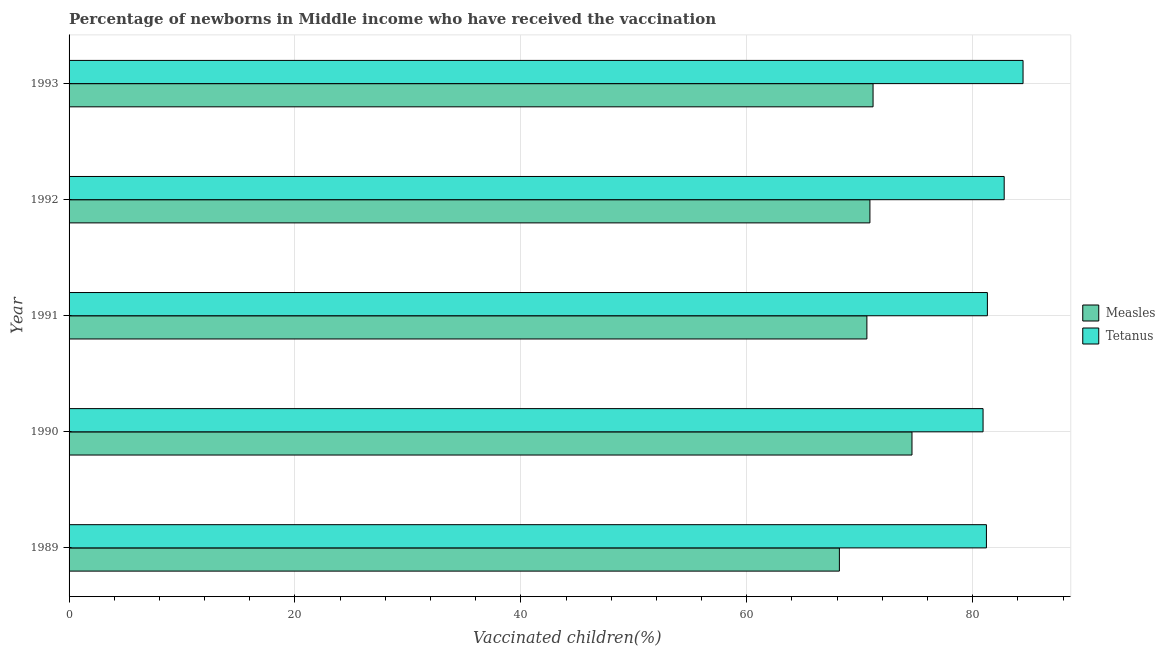Are the number of bars on each tick of the Y-axis equal?
Provide a succinct answer. Yes. In how many cases, is the number of bars for a given year not equal to the number of legend labels?
Make the answer very short. 0. What is the percentage of newborns who received vaccination for tetanus in 1989?
Give a very brief answer. 81.22. Across all years, what is the maximum percentage of newborns who received vaccination for tetanus?
Keep it short and to the point. 84.46. Across all years, what is the minimum percentage of newborns who received vaccination for measles?
Your answer should be very brief. 68.2. What is the total percentage of newborns who received vaccination for measles in the graph?
Offer a terse response. 355.55. What is the difference between the percentage of newborns who received vaccination for measles in 1989 and that in 1992?
Offer a very short reply. -2.7. What is the difference between the percentage of newborns who received vaccination for tetanus in 1992 and the percentage of newborns who received vaccination for measles in 1993?
Offer a very short reply. 11.61. What is the average percentage of newborns who received vaccination for tetanus per year?
Offer a terse response. 82.14. In the year 1993, what is the difference between the percentage of newborns who received vaccination for measles and percentage of newborns who received vaccination for tetanus?
Your answer should be compact. -13.28. What is the ratio of the percentage of newborns who received vaccination for measles in 1989 to that in 1990?
Keep it short and to the point. 0.91. Is the percentage of newborns who received vaccination for measles in 1989 less than that in 1993?
Your answer should be compact. Yes. Is the difference between the percentage of newborns who received vaccination for tetanus in 1990 and 1992 greater than the difference between the percentage of newborns who received vaccination for measles in 1990 and 1992?
Offer a terse response. No. What is the difference between the highest and the second highest percentage of newborns who received vaccination for measles?
Your answer should be compact. 3.45. What is the difference between the highest and the lowest percentage of newborns who received vaccination for measles?
Your answer should be compact. 6.43. In how many years, is the percentage of newborns who received vaccination for tetanus greater than the average percentage of newborns who received vaccination for tetanus taken over all years?
Offer a very short reply. 2. Is the sum of the percentage of newborns who received vaccination for tetanus in 1989 and 1993 greater than the maximum percentage of newborns who received vaccination for measles across all years?
Offer a terse response. Yes. What does the 1st bar from the top in 1989 represents?
Ensure brevity in your answer.  Tetanus. What does the 2nd bar from the bottom in 1991 represents?
Make the answer very short. Tetanus. Are all the bars in the graph horizontal?
Your response must be concise. Yes. What is the difference between two consecutive major ticks on the X-axis?
Your response must be concise. 20. How are the legend labels stacked?
Make the answer very short. Vertical. What is the title of the graph?
Give a very brief answer. Percentage of newborns in Middle income who have received the vaccination. Does "Overweight" appear as one of the legend labels in the graph?
Ensure brevity in your answer.  No. What is the label or title of the X-axis?
Provide a short and direct response. Vaccinated children(%)
. What is the Vaccinated children(%)
 of Measles in 1989?
Ensure brevity in your answer.  68.2. What is the Vaccinated children(%)
 in Tetanus in 1989?
Provide a short and direct response. 81.22. What is the Vaccinated children(%)
 in Measles in 1990?
Offer a terse response. 74.63. What is the Vaccinated children(%)
 of Tetanus in 1990?
Your answer should be very brief. 80.92. What is the Vaccinated children(%)
 in Measles in 1991?
Your answer should be compact. 70.64. What is the Vaccinated children(%)
 in Tetanus in 1991?
Make the answer very short. 81.3. What is the Vaccinated children(%)
 in Measles in 1992?
Keep it short and to the point. 70.9. What is the Vaccinated children(%)
 of Tetanus in 1992?
Your response must be concise. 82.79. What is the Vaccinated children(%)
 in Measles in 1993?
Your response must be concise. 71.18. What is the Vaccinated children(%)
 of Tetanus in 1993?
Your answer should be very brief. 84.46. Across all years, what is the maximum Vaccinated children(%)
 in Measles?
Offer a very short reply. 74.63. Across all years, what is the maximum Vaccinated children(%)
 of Tetanus?
Give a very brief answer. 84.46. Across all years, what is the minimum Vaccinated children(%)
 in Measles?
Give a very brief answer. 68.2. Across all years, what is the minimum Vaccinated children(%)
 of Tetanus?
Ensure brevity in your answer.  80.92. What is the total Vaccinated children(%)
 of Measles in the graph?
Offer a very short reply. 355.55. What is the total Vaccinated children(%)
 in Tetanus in the graph?
Offer a terse response. 410.7. What is the difference between the Vaccinated children(%)
 of Measles in 1989 and that in 1990?
Provide a succinct answer. -6.43. What is the difference between the Vaccinated children(%)
 in Tetanus in 1989 and that in 1990?
Keep it short and to the point. 0.3. What is the difference between the Vaccinated children(%)
 of Measles in 1989 and that in 1991?
Give a very brief answer. -2.43. What is the difference between the Vaccinated children(%)
 in Tetanus in 1989 and that in 1991?
Offer a terse response. -0.09. What is the difference between the Vaccinated children(%)
 in Measles in 1989 and that in 1992?
Ensure brevity in your answer.  -2.7. What is the difference between the Vaccinated children(%)
 in Tetanus in 1989 and that in 1992?
Offer a terse response. -1.57. What is the difference between the Vaccinated children(%)
 in Measles in 1989 and that in 1993?
Ensure brevity in your answer.  -2.98. What is the difference between the Vaccinated children(%)
 of Tetanus in 1989 and that in 1993?
Ensure brevity in your answer.  -3.24. What is the difference between the Vaccinated children(%)
 of Measles in 1990 and that in 1991?
Keep it short and to the point. 3.99. What is the difference between the Vaccinated children(%)
 of Tetanus in 1990 and that in 1991?
Provide a short and direct response. -0.38. What is the difference between the Vaccinated children(%)
 of Measles in 1990 and that in 1992?
Offer a very short reply. 3.72. What is the difference between the Vaccinated children(%)
 in Tetanus in 1990 and that in 1992?
Your answer should be very brief. -1.87. What is the difference between the Vaccinated children(%)
 of Measles in 1990 and that in 1993?
Provide a succinct answer. 3.45. What is the difference between the Vaccinated children(%)
 of Tetanus in 1990 and that in 1993?
Offer a terse response. -3.54. What is the difference between the Vaccinated children(%)
 in Measles in 1991 and that in 1992?
Offer a terse response. -0.27. What is the difference between the Vaccinated children(%)
 in Tetanus in 1991 and that in 1992?
Give a very brief answer. -1.49. What is the difference between the Vaccinated children(%)
 of Measles in 1991 and that in 1993?
Your answer should be compact. -0.55. What is the difference between the Vaccinated children(%)
 of Tetanus in 1991 and that in 1993?
Keep it short and to the point. -3.16. What is the difference between the Vaccinated children(%)
 of Measles in 1992 and that in 1993?
Provide a succinct answer. -0.28. What is the difference between the Vaccinated children(%)
 in Tetanus in 1992 and that in 1993?
Your answer should be compact. -1.67. What is the difference between the Vaccinated children(%)
 of Measles in 1989 and the Vaccinated children(%)
 of Tetanus in 1990?
Your answer should be very brief. -12.72. What is the difference between the Vaccinated children(%)
 in Measles in 1989 and the Vaccinated children(%)
 in Tetanus in 1991?
Ensure brevity in your answer.  -13.1. What is the difference between the Vaccinated children(%)
 in Measles in 1989 and the Vaccinated children(%)
 in Tetanus in 1992?
Keep it short and to the point. -14.59. What is the difference between the Vaccinated children(%)
 of Measles in 1989 and the Vaccinated children(%)
 of Tetanus in 1993?
Your answer should be compact. -16.26. What is the difference between the Vaccinated children(%)
 in Measles in 1990 and the Vaccinated children(%)
 in Tetanus in 1991?
Make the answer very short. -6.68. What is the difference between the Vaccinated children(%)
 in Measles in 1990 and the Vaccinated children(%)
 in Tetanus in 1992?
Ensure brevity in your answer.  -8.16. What is the difference between the Vaccinated children(%)
 in Measles in 1990 and the Vaccinated children(%)
 in Tetanus in 1993?
Provide a short and direct response. -9.83. What is the difference between the Vaccinated children(%)
 of Measles in 1991 and the Vaccinated children(%)
 of Tetanus in 1992?
Your answer should be compact. -12.16. What is the difference between the Vaccinated children(%)
 of Measles in 1991 and the Vaccinated children(%)
 of Tetanus in 1993?
Your answer should be very brief. -13.83. What is the difference between the Vaccinated children(%)
 in Measles in 1992 and the Vaccinated children(%)
 in Tetanus in 1993?
Ensure brevity in your answer.  -13.56. What is the average Vaccinated children(%)
 in Measles per year?
Provide a short and direct response. 71.11. What is the average Vaccinated children(%)
 in Tetanus per year?
Provide a succinct answer. 82.14. In the year 1989, what is the difference between the Vaccinated children(%)
 of Measles and Vaccinated children(%)
 of Tetanus?
Make the answer very short. -13.02. In the year 1990, what is the difference between the Vaccinated children(%)
 of Measles and Vaccinated children(%)
 of Tetanus?
Provide a short and direct response. -6.29. In the year 1991, what is the difference between the Vaccinated children(%)
 of Measles and Vaccinated children(%)
 of Tetanus?
Your response must be concise. -10.67. In the year 1992, what is the difference between the Vaccinated children(%)
 in Measles and Vaccinated children(%)
 in Tetanus?
Give a very brief answer. -11.89. In the year 1993, what is the difference between the Vaccinated children(%)
 of Measles and Vaccinated children(%)
 of Tetanus?
Provide a short and direct response. -13.28. What is the ratio of the Vaccinated children(%)
 of Measles in 1989 to that in 1990?
Ensure brevity in your answer.  0.91. What is the ratio of the Vaccinated children(%)
 of Measles in 1989 to that in 1991?
Your answer should be very brief. 0.97. What is the ratio of the Vaccinated children(%)
 of Measles in 1989 to that in 1992?
Provide a short and direct response. 0.96. What is the ratio of the Vaccinated children(%)
 of Tetanus in 1989 to that in 1992?
Offer a terse response. 0.98. What is the ratio of the Vaccinated children(%)
 of Measles in 1989 to that in 1993?
Make the answer very short. 0.96. What is the ratio of the Vaccinated children(%)
 in Tetanus in 1989 to that in 1993?
Your answer should be compact. 0.96. What is the ratio of the Vaccinated children(%)
 in Measles in 1990 to that in 1991?
Your answer should be compact. 1.06. What is the ratio of the Vaccinated children(%)
 in Measles in 1990 to that in 1992?
Offer a very short reply. 1.05. What is the ratio of the Vaccinated children(%)
 of Tetanus in 1990 to that in 1992?
Offer a very short reply. 0.98. What is the ratio of the Vaccinated children(%)
 in Measles in 1990 to that in 1993?
Offer a terse response. 1.05. What is the ratio of the Vaccinated children(%)
 in Tetanus in 1990 to that in 1993?
Your answer should be very brief. 0.96. What is the ratio of the Vaccinated children(%)
 in Measles in 1991 to that in 1993?
Make the answer very short. 0.99. What is the ratio of the Vaccinated children(%)
 in Tetanus in 1991 to that in 1993?
Keep it short and to the point. 0.96. What is the ratio of the Vaccinated children(%)
 of Measles in 1992 to that in 1993?
Your response must be concise. 1. What is the ratio of the Vaccinated children(%)
 in Tetanus in 1992 to that in 1993?
Provide a succinct answer. 0.98. What is the difference between the highest and the second highest Vaccinated children(%)
 of Measles?
Offer a very short reply. 3.45. What is the difference between the highest and the second highest Vaccinated children(%)
 of Tetanus?
Your response must be concise. 1.67. What is the difference between the highest and the lowest Vaccinated children(%)
 of Measles?
Your answer should be compact. 6.43. What is the difference between the highest and the lowest Vaccinated children(%)
 of Tetanus?
Provide a short and direct response. 3.54. 